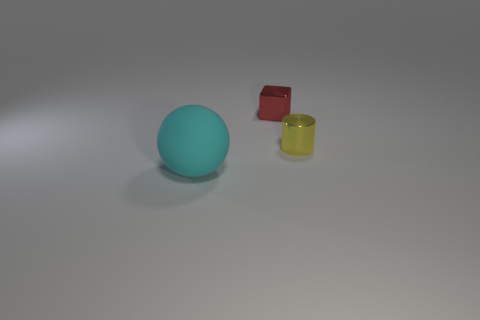How many other objects are there of the same shape as the yellow shiny object? 0 